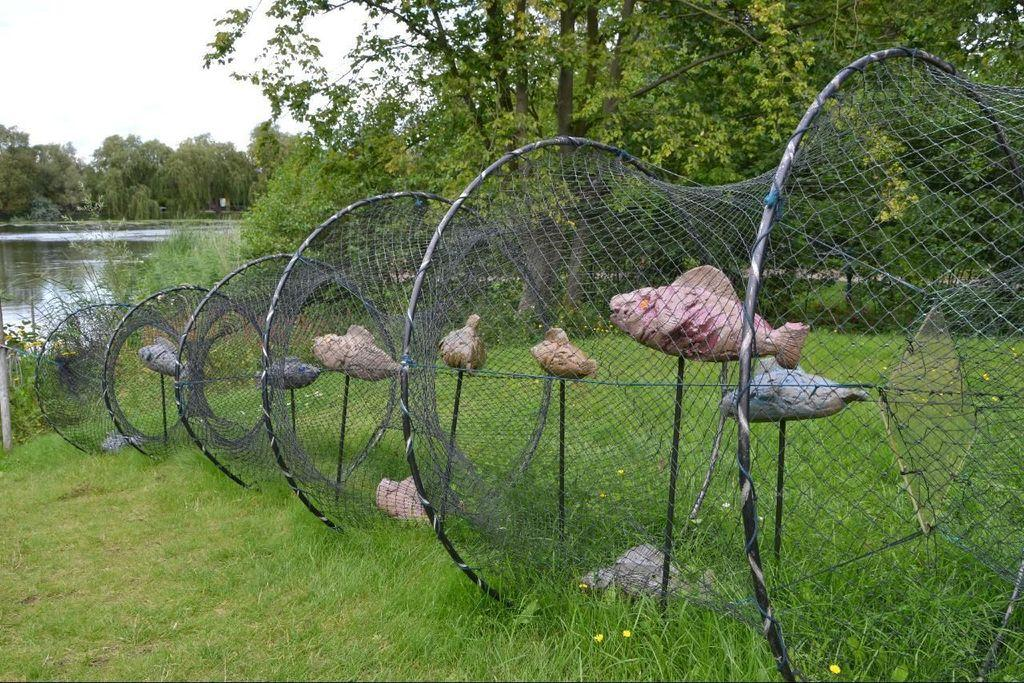What is contained in the net in the image? There are fishes in a net in the image. What body of water is visible in the image? There is a lake visible in the image. What type of vegetation is present around the lake? There are trees around the lake. What type of ground cover is visible in the image? There is grass visible in the image. What is the opinion of the copper on the fishes in the image? There is no copper present in the image, and therefore no opinion can be attributed to it. 